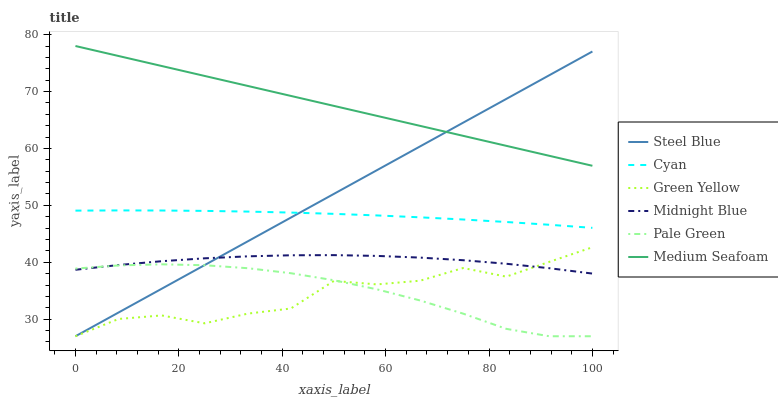Does Green Yellow have the minimum area under the curve?
Answer yes or no. Yes. Does Medium Seafoam have the maximum area under the curve?
Answer yes or no. Yes. Does Steel Blue have the minimum area under the curve?
Answer yes or no. No. Does Steel Blue have the maximum area under the curve?
Answer yes or no. No. Is Steel Blue the smoothest?
Answer yes or no. Yes. Is Green Yellow the roughest?
Answer yes or no. Yes. Is Pale Green the smoothest?
Answer yes or no. No. Is Pale Green the roughest?
Answer yes or no. No. Does Steel Blue have the lowest value?
Answer yes or no. Yes. Does Cyan have the lowest value?
Answer yes or no. No. Does Medium Seafoam have the highest value?
Answer yes or no. Yes. Does Steel Blue have the highest value?
Answer yes or no. No. Is Pale Green less than Cyan?
Answer yes or no. Yes. Is Medium Seafoam greater than Pale Green?
Answer yes or no. Yes. Does Steel Blue intersect Green Yellow?
Answer yes or no. Yes. Is Steel Blue less than Green Yellow?
Answer yes or no. No. Is Steel Blue greater than Green Yellow?
Answer yes or no. No. Does Pale Green intersect Cyan?
Answer yes or no. No. 